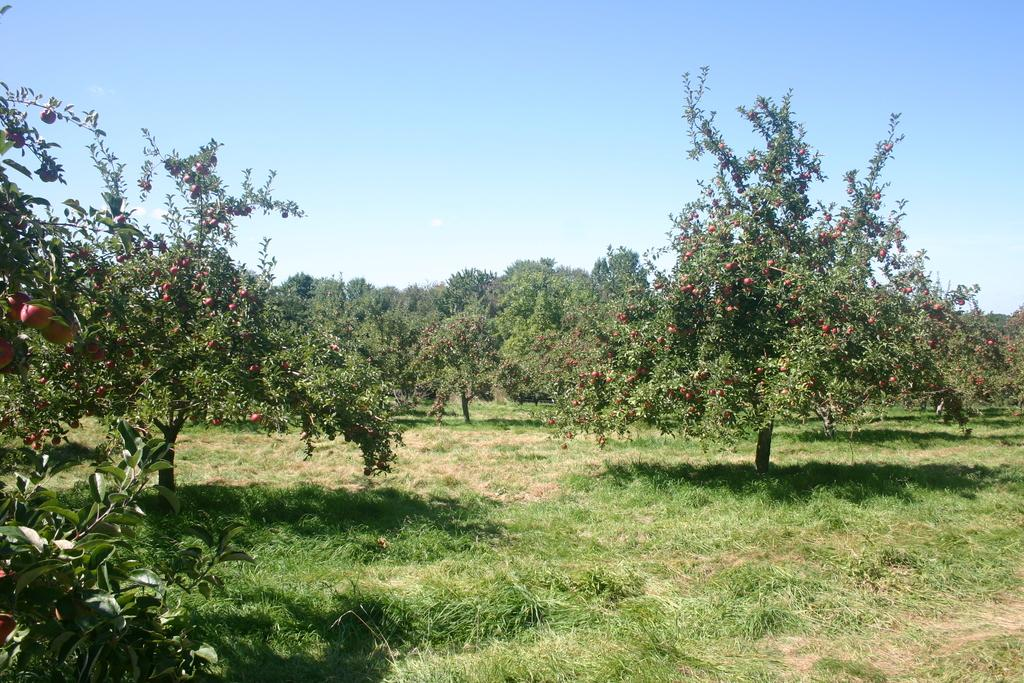What type of terrain is visible at the bottom of the image? There is grassland at the bottom side of the image. What other natural elements can be seen in the image? There are trees around the area of the image. What type of face can be seen on the pig in the image? There is no pig or face present in the image; it features grassland and trees. 